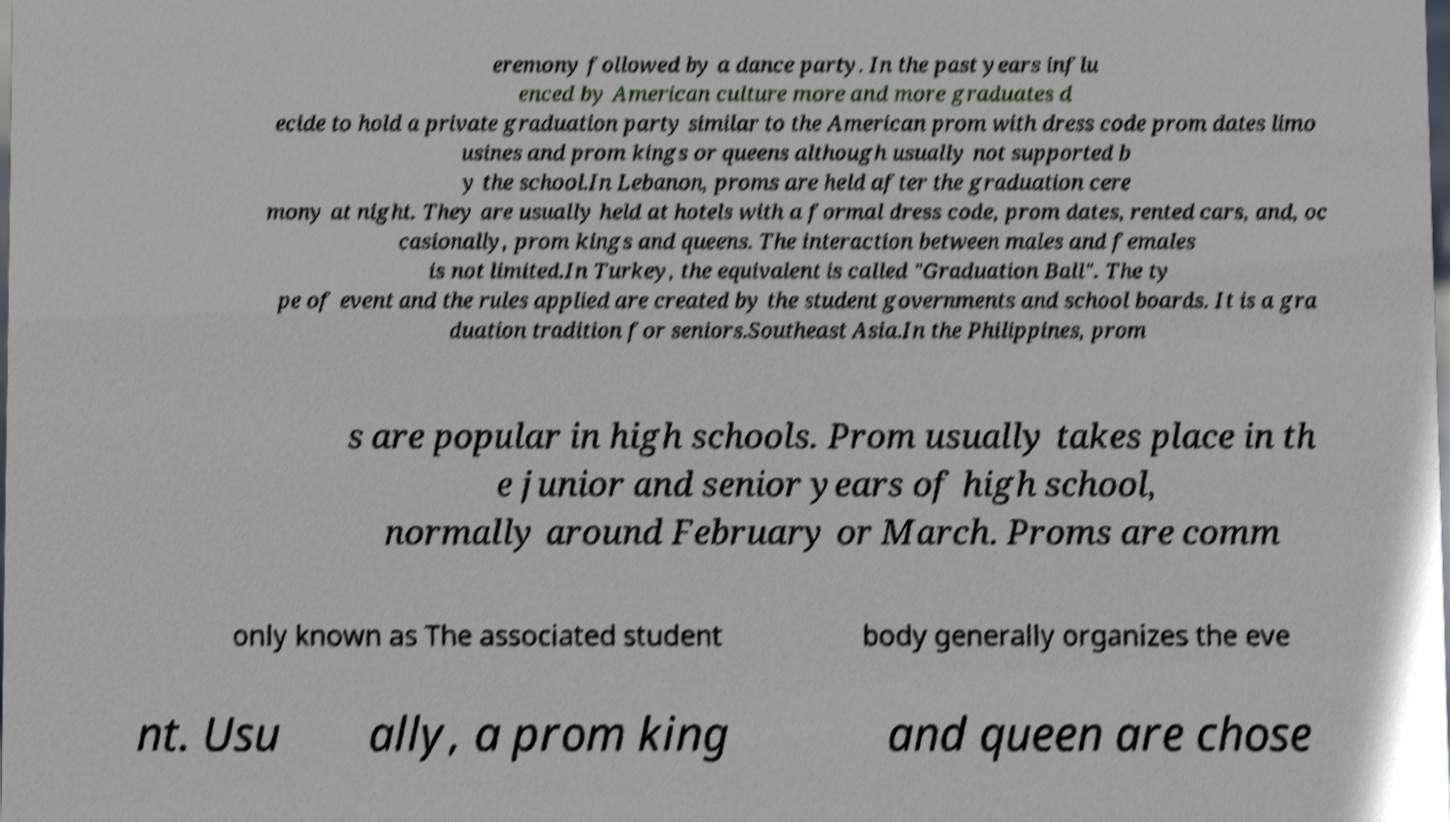Can you read and provide the text displayed in the image?This photo seems to have some interesting text. Can you extract and type it out for me? eremony followed by a dance party. In the past years influ enced by American culture more and more graduates d ecide to hold a private graduation party similar to the American prom with dress code prom dates limo usines and prom kings or queens although usually not supported b y the school.In Lebanon, proms are held after the graduation cere mony at night. They are usually held at hotels with a formal dress code, prom dates, rented cars, and, oc casionally, prom kings and queens. The interaction between males and females is not limited.In Turkey, the equivalent is called "Graduation Ball". The ty pe of event and the rules applied are created by the student governments and school boards. It is a gra duation tradition for seniors.Southeast Asia.In the Philippines, prom s are popular in high schools. Prom usually takes place in th e junior and senior years of high school, normally around February or March. Proms are comm only known as The associated student body generally organizes the eve nt. Usu ally, a prom king and queen are chose 